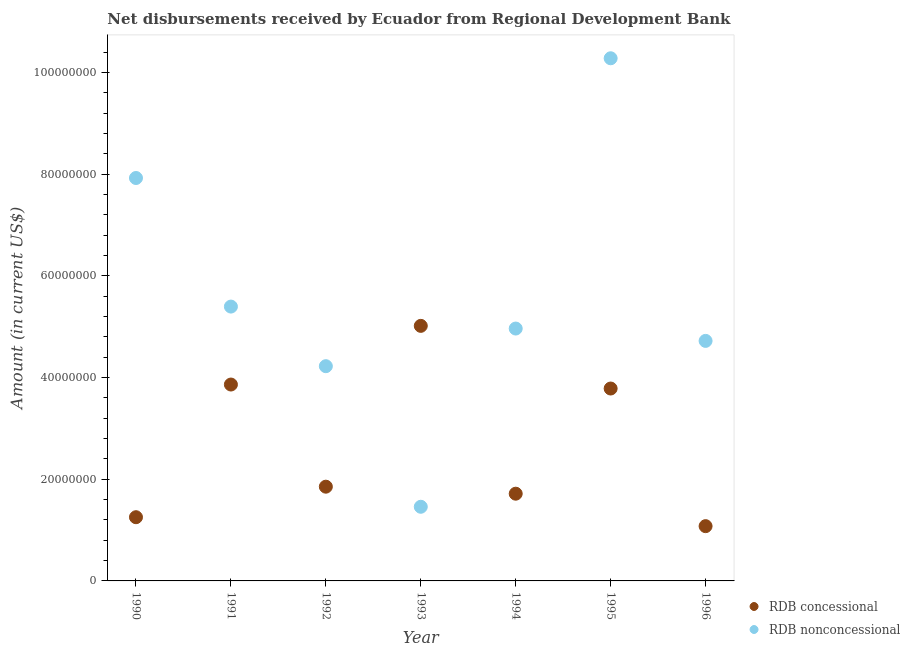Is the number of dotlines equal to the number of legend labels?
Your answer should be compact. Yes. What is the net concessional disbursements from rdb in 1991?
Ensure brevity in your answer.  3.86e+07. Across all years, what is the maximum net concessional disbursements from rdb?
Your answer should be compact. 5.02e+07. Across all years, what is the minimum net concessional disbursements from rdb?
Give a very brief answer. 1.08e+07. In which year was the net concessional disbursements from rdb maximum?
Provide a short and direct response. 1993. What is the total net non concessional disbursements from rdb in the graph?
Offer a terse response. 3.90e+08. What is the difference between the net concessional disbursements from rdb in 1990 and that in 1992?
Ensure brevity in your answer.  -6.00e+06. What is the difference between the net concessional disbursements from rdb in 1990 and the net non concessional disbursements from rdb in 1991?
Offer a terse response. -4.14e+07. What is the average net concessional disbursements from rdb per year?
Offer a terse response. 2.65e+07. In the year 1991, what is the difference between the net concessional disbursements from rdb and net non concessional disbursements from rdb?
Ensure brevity in your answer.  -1.53e+07. What is the ratio of the net concessional disbursements from rdb in 1994 to that in 1995?
Your answer should be compact. 0.45. Is the difference between the net non concessional disbursements from rdb in 1991 and 1995 greater than the difference between the net concessional disbursements from rdb in 1991 and 1995?
Make the answer very short. No. What is the difference between the highest and the second highest net non concessional disbursements from rdb?
Offer a very short reply. 2.35e+07. What is the difference between the highest and the lowest net concessional disbursements from rdb?
Offer a very short reply. 3.94e+07. In how many years, is the net non concessional disbursements from rdb greater than the average net non concessional disbursements from rdb taken over all years?
Offer a terse response. 2. Is the sum of the net concessional disbursements from rdb in 1990 and 1993 greater than the maximum net non concessional disbursements from rdb across all years?
Provide a short and direct response. No. Does the net non concessional disbursements from rdb monotonically increase over the years?
Provide a succinct answer. No. Is the net concessional disbursements from rdb strictly less than the net non concessional disbursements from rdb over the years?
Provide a short and direct response. No. How many years are there in the graph?
Provide a short and direct response. 7. What is the difference between two consecutive major ticks on the Y-axis?
Make the answer very short. 2.00e+07. Does the graph contain any zero values?
Your answer should be compact. No. Does the graph contain grids?
Provide a succinct answer. No. How are the legend labels stacked?
Provide a short and direct response. Vertical. What is the title of the graph?
Your response must be concise. Net disbursements received by Ecuador from Regional Development Bank. Does "Passenger Transport Items" appear as one of the legend labels in the graph?
Make the answer very short. No. What is the Amount (in current US$) of RDB concessional in 1990?
Give a very brief answer. 1.25e+07. What is the Amount (in current US$) in RDB nonconcessional in 1990?
Make the answer very short. 7.92e+07. What is the Amount (in current US$) in RDB concessional in 1991?
Give a very brief answer. 3.86e+07. What is the Amount (in current US$) in RDB nonconcessional in 1991?
Your answer should be compact. 5.39e+07. What is the Amount (in current US$) of RDB concessional in 1992?
Provide a short and direct response. 1.85e+07. What is the Amount (in current US$) of RDB nonconcessional in 1992?
Your answer should be compact. 4.22e+07. What is the Amount (in current US$) in RDB concessional in 1993?
Ensure brevity in your answer.  5.02e+07. What is the Amount (in current US$) of RDB nonconcessional in 1993?
Ensure brevity in your answer.  1.46e+07. What is the Amount (in current US$) in RDB concessional in 1994?
Your answer should be very brief. 1.72e+07. What is the Amount (in current US$) in RDB nonconcessional in 1994?
Your answer should be very brief. 4.96e+07. What is the Amount (in current US$) in RDB concessional in 1995?
Your answer should be compact. 3.78e+07. What is the Amount (in current US$) in RDB nonconcessional in 1995?
Ensure brevity in your answer.  1.03e+08. What is the Amount (in current US$) of RDB concessional in 1996?
Offer a very short reply. 1.08e+07. What is the Amount (in current US$) of RDB nonconcessional in 1996?
Provide a short and direct response. 4.72e+07. Across all years, what is the maximum Amount (in current US$) in RDB concessional?
Your answer should be very brief. 5.02e+07. Across all years, what is the maximum Amount (in current US$) of RDB nonconcessional?
Your answer should be compact. 1.03e+08. Across all years, what is the minimum Amount (in current US$) in RDB concessional?
Make the answer very short. 1.08e+07. Across all years, what is the minimum Amount (in current US$) of RDB nonconcessional?
Provide a short and direct response. 1.46e+07. What is the total Amount (in current US$) of RDB concessional in the graph?
Offer a terse response. 1.86e+08. What is the total Amount (in current US$) in RDB nonconcessional in the graph?
Ensure brevity in your answer.  3.90e+08. What is the difference between the Amount (in current US$) in RDB concessional in 1990 and that in 1991?
Your answer should be compact. -2.61e+07. What is the difference between the Amount (in current US$) in RDB nonconcessional in 1990 and that in 1991?
Your answer should be compact. 2.53e+07. What is the difference between the Amount (in current US$) of RDB concessional in 1990 and that in 1992?
Provide a succinct answer. -6.00e+06. What is the difference between the Amount (in current US$) of RDB nonconcessional in 1990 and that in 1992?
Your answer should be very brief. 3.70e+07. What is the difference between the Amount (in current US$) in RDB concessional in 1990 and that in 1993?
Provide a short and direct response. -3.76e+07. What is the difference between the Amount (in current US$) of RDB nonconcessional in 1990 and that in 1993?
Keep it short and to the point. 6.46e+07. What is the difference between the Amount (in current US$) in RDB concessional in 1990 and that in 1994?
Make the answer very short. -4.62e+06. What is the difference between the Amount (in current US$) of RDB nonconcessional in 1990 and that in 1994?
Offer a terse response. 2.96e+07. What is the difference between the Amount (in current US$) of RDB concessional in 1990 and that in 1995?
Your answer should be compact. -2.53e+07. What is the difference between the Amount (in current US$) of RDB nonconcessional in 1990 and that in 1995?
Keep it short and to the point. -2.35e+07. What is the difference between the Amount (in current US$) of RDB concessional in 1990 and that in 1996?
Keep it short and to the point. 1.76e+06. What is the difference between the Amount (in current US$) of RDB nonconcessional in 1990 and that in 1996?
Give a very brief answer. 3.20e+07. What is the difference between the Amount (in current US$) of RDB concessional in 1991 and that in 1992?
Make the answer very short. 2.01e+07. What is the difference between the Amount (in current US$) of RDB nonconcessional in 1991 and that in 1992?
Your response must be concise. 1.17e+07. What is the difference between the Amount (in current US$) of RDB concessional in 1991 and that in 1993?
Offer a terse response. -1.15e+07. What is the difference between the Amount (in current US$) of RDB nonconcessional in 1991 and that in 1993?
Your answer should be very brief. 3.94e+07. What is the difference between the Amount (in current US$) in RDB concessional in 1991 and that in 1994?
Provide a short and direct response. 2.15e+07. What is the difference between the Amount (in current US$) of RDB nonconcessional in 1991 and that in 1994?
Your answer should be compact. 4.32e+06. What is the difference between the Amount (in current US$) of RDB concessional in 1991 and that in 1995?
Keep it short and to the point. 7.85e+05. What is the difference between the Amount (in current US$) in RDB nonconcessional in 1991 and that in 1995?
Your answer should be very brief. -4.88e+07. What is the difference between the Amount (in current US$) of RDB concessional in 1991 and that in 1996?
Keep it short and to the point. 2.78e+07. What is the difference between the Amount (in current US$) in RDB nonconcessional in 1991 and that in 1996?
Keep it short and to the point. 6.74e+06. What is the difference between the Amount (in current US$) of RDB concessional in 1992 and that in 1993?
Your response must be concise. -3.16e+07. What is the difference between the Amount (in current US$) in RDB nonconcessional in 1992 and that in 1993?
Your response must be concise. 2.76e+07. What is the difference between the Amount (in current US$) of RDB concessional in 1992 and that in 1994?
Ensure brevity in your answer.  1.38e+06. What is the difference between the Amount (in current US$) of RDB nonconcessional in 1992 and that in 1994?
Make the answer very short. -7.40e+06. What is the difference between the Amount (in current US$) in RDB concessional in 1992 and that in 1995?
Your response must be concise. -1.93e+07. What is the difference between the Amount (in current US$) of RDB nonconcessional in 1992 and that in 1995?
Provide a short and direct response. -6.05e+07. What is the difference between the Amount (in current US$) in RDB concessional in 1992 and that in 1996?
Provide a succinct answer. 7.76e+06. What is the difference between the Amount (in current US$) in RDB nonconcessional in 1992 and that in 1996?
Your answer should be very brief. -4.97e+06. What is the difference between the Amount (in current US$) of RDB concessional in 1993 and that in 1994?
Make the answer very short. 3.30e+07. What is the difference between the Amount (in current US$) in RDB nonconcessional in 1993 and that in 1994?
Provide a short and direct response. -3.50e+07. What is the difference between the Amount (in current US$) in RDB concessional in 1993 and that in 1995?
Your answer should be compact. 1.23e+07. What is the difference between the Amount (in current US$) in RDB nonconcessional in 1993 and that in 1995?
Make the answer very short. -8.82e+07. What is the difference between the Amount (in current US$) of RDB concessional in 1993 and that in 1996?
Make the answer very short. 3.94e+07. What is the difference between the Amount (in current US$) of RDB nonconcessional in 1993 and that in 1996?
Provide a succinct answer. -3.26e+07. What is the difference between the Amount (in current US$) in RDB concessional in 1994 and that in 1995?
Give a very brief answer. -2.07e+07. What is the difference between the Amount (in current US$) in RDB nonconcessional in 1994 and that in 1995?
Your response must be concise. -5.31e+07. What is the difference between the Amount (in current US$) of RDB concessional in 1994 and that in 1996?
Ensure brevity in your answer.  6.38e+06. What is the difference between the Amount (in current US$) in RDB nonconcessional in 1994 and that in 1996?
Keep it short and to the point. 2.43e+06. What is the difference between the Amount (in current US$) of RDB concessional in 1995 and that in 1996?
Give a very brief answer. 2.71e+07. What is the difference between the Amount (in current US$) of RDB nonconcessional in 1995 and that in 1996?
Provide a short and direct response. 5.56e+07. What is the difference between the Amount (in current US$) of RDB concessional in 1990 and the Amount (in current US$) of RDB nonconcessional in 1991?
Ensure brevity in your answer.  -4.14e+07. What is the difference between the Amount (in current US$) in RDB concessional in 1990 and the Amount (in current US$) in RDB nonconcessional in 1992?
Your answer should be compact. -2.97e+07. What is the difference between the Amount (in current US$) in RDB concessional in 1990 and the Amount (in current US$) in RDB nonconcessional in 1993?
Your answer should be compact. -2.05e+06. What is the difference between the Amount (in current US$) in RDB concessional in 1990 and the Amount (in current US$) in RDB nonconcessional in 1994?
Keep it short and to the point. -3.71e+07. What is the difference between the Amount (in current US$) in RDB concessional in 1990 and the Amount (in current US$) in RDB nonconcessional in 1995?
Your response must be concise. -9.02e+07. What is the difference between the Amount (in current US$) of RDB concessional in 1990 and the Amount (in current US$) of RDB nonconcessional in 1996?
Offer a terse response. -3.47e+07. What is the difference between the Amount (in current US$) of RDB concessional in 1991 and the Amount (in current US$) of RDB nonconcessional in 1992?
Offer a terse response. -3.61e+06. What is the difference between the Amount (in current US$) in RDB concessional in 1991 and the Amount (in current US$) in RDB nonconcessional in 1993?
Provide a succinct answer. 2.40e+07. What is the difference between the Amount (in current US$) in RDB concessional in 1991 and the Amount (in current US$) in RDB nonconcessional in 1994?
Provide a succinct answer. -1.10e+07. What is the difference between the Amount (in current US$) in RDB concessional in 1991 and the Amount (in current US$) in RDB nonconcessional in 1995?
Offer a very short reply. -6.42e+07. What is the difference between the Amount (in current US$) of RDB concessional in 1991 and the Amount (in current US$) of RDB nonconcessional in 1996?
Your response must be concise. -8.58e+06. What is the difference between the Amount (in current US$) in RDB concessional in 1992 and the Amount (in current US$) in RDB nonconcessional in 1993?
Give a very brief answer. 3.95e+06. What is the difference between the Amount (in current US$) in RDB concessional in 1992 and the Amount (in current US$) in RDB nonconcessional in 1994?
Make the answer very short. -3.11e+07. What is the difference between the Amount (in current US$) in RDB concessional in 1992 and the Amount (in current US$) in RDB nonconcessional in 1995?
Your answer should be compact. -8.42e+07. What is the difference between the Amount (in current US$) of RDB concessional in 1992 and the Amount (in current US$) of RDB nonconcessional in 1996?
Offer a terse response. -2.87e+07. What is the difference between the Amount (in current US$) in RDB concessional in 1993 and the Amount (in current US$) in RDB nonconcessional in 1994?
Provide a succinct answer. 5.28e+05. What is the difference between the Amount (in current US$) of RDB concessional in 1993 and the Amount (in current US$) of RDB nonconcessional in 1995?
Ensure brevity in your answer.  -5.26e+07. What is the difference between the Amount (in current US$) in RDB concessional in 1993 and the Amount (in current US$) in RDB nonconcessional in 1996?
Offer a very short reply. 2.96e+06. What is the difference between the Amount (in current US$) in RDB concessional in 1994 and the Amount (in current US$) in RDB nonconcessional in 1995?
Your answer should be very brief. -8.56e+07. What is the difference between the Amount (in current US$) of RDB concessional in 1994 and the Amount (in current US$) of RDB nonconcessional in 1996?
Make the answer very short. -3.00e+07. What is the difference between the Amount (in current US$) of RDB concessional in 1995 and the Amount (in current US$) of RDB nonconcessional in 1996?
Provide a short and direct response. -9.37e+06. What is the average Amount (in current US$) of RDB concessional per year?
Make the answer very short. 2.65e+07. What is the average Amount (in current US$) of RDB nonconcessional per year?
Give a very brief answer. 5.57e+07. In the year 1990, what is the difference between the Amount (in current US$) of RDB concessional and Amount (in current US$) of RDB nonconcessional?
Give a very brief answer. -6.67e+07. In the year 1991, what is the difference between the Amount (in current US$) in RDB concessional and Amount (in current US$) in RDB nonconcessional?
Provide a short and direct response. -1.53e+07. In the year 1992, what is the difference between the Amount (in current US$) in RDB concessional and Amount (in current US$) in RDB nonconcessional?
Provide a succinct answer. -2.37e+07. In the year 1993, what is the difference between the Amount (in current US$) in RDB concessional and Amount (in current US$) in RDB nonconcessional?
Provide a succinct answer. 3.56e+07. In the year 1994, what is the difference between the Amount (in current US$) of RDB concessional and Amount (in current US$) of RDB nonconcessional?
Your response must be concise. -3.25e+07. In the year 1995, what is the difference between the Amount (in current US$) in RDB concessional and Amount (in current US$) in RDB nonconcessional?
Offer a terse response. -6.49e+07. In the year 1996, what is the difference between the Amount (in current US$) in RDB concessional and Amount (in current US$) in RDB nonconcessional?
Make the answer very short. -3.64e+07. What is the ratio of the Amount (in current US$) of RDB concessional in 1990 to that in 1991?
Provide a succinct answer. 0.32. What is the ratio of the Amount (in current US$) of RDB nonconcessional in 1990 to that in 1991?
Offer a very short reply. 1.47. What is the ratio of the Amount (in current US$) of RDB concessional in 1990 to that in 1992?
Ensure brevity in your answer.  0.68. What is the ratio of the Amount (in current US$) of RDB nonconcessional in 1990 to that in 1992?
Ensure brevity in your answer.  1.88. What is the ratio of the Amount (in current US$) of RDB concessional in 1990 to that in 1993?
Your response must be concise. 0.25. What is the ratio of the Amount (in current US$) of RDB nonconcessional in 1990 to that in 1993?
Offer a very short reply. 5.43. What is the ratio of the Amount (in current US$) in RDB concessional in 1990 to that in 1994?
Your answer should be very brief. 0.73. What is the ratio of the Amount (in current US$) in RDB nonconcessional in 1990 to that in 1994?
Ensure brevity in your answer.  1.6. What is the ratio of the Amount (in current US$) of RDB concessional in 1990 to that in 1995?
Offer a terse response. 0.33. What is the ratio of the Amount (in current US$) of RDB nonconcessional in 1990 to that in 1995?
Provide a succinct answer. 0.77. What is the ratio of the Amount (in current US$) of RDB concessional in 1990 to that in 1996?
Your response must be concise. 1.16. What is the ratio of the Amount (in current US$) in RDB nonconcessional in 1990 to that in 1996?
Your response must be concise. 1.68. What is the ratio of the Amount (in current US$) in RDB concessional in 1991 to that in 1992?
Your answer should be compact. 2.08. What is the ratio of the Amount (in current US$) of RDB nonconcessional in 1991 to that in 1992?
Make the answer very short. 1.28. What is the ratio of the Amount (in current US$) of RDB concessional in 1991 to that in 1993?
Ensure brevity in your answer.  0.77. What is the ratio of the Amount (in current US$) of RDB nonconcessional in 1991 to that in 1993?
Your answer should be very brief. 3.7. What is the ratio of the Amount (in current US$) of RDB concessional in 1991 to that in 1994?
Keep it short and to the point. 2.25. What is the ratio of the Amount (in current US$) of RDB nonconcessional in 1991 to that in 1994?
Offer a terse response. 1.09. What is the ratio of the Amount (in current US$) of RDB concessional in 1991 to that in 1995?
Provide a short and direct response. 1.02. What is the ratio of the Amount (in current US$) in RDB nonconcessional in 1991 to that in 1995?
Provide a succinct answer. 0.52. What is the ratio of the Amount (in current US$) in RDB concessional in 1991 to that in 1996?
Provide a short and direct response. 3.59. What is the ratio of the Amount (in current US$) in RDB concessional in 1992 to that in 1993?
Your response must be concise. 0.37. What is the ratio of the Amount (in current US$) of RDB nonconcessional in 1992 to that in 1993?
Keep it short and to the point. 2.9. What is the ratio of the Amount (in current US$) in RDB concessional in 1992 to that in 1994?
Your answer should be compact. 1.08. What is the ratio of the Amount (in current US$) of RDB nonconcessional in 1992 to that in 1994?
Your response must be concise. 0.85. What is the ratio of the Amount (in current US$) in RDB concessional in 1992 to that in 1995?
Give a very brief answer. 0.49. What is the ratio of the Amount (in current US$) of RDB nonconcessional in 1992 to that in 1995?
Offer a very short reply. 0.41. What is the ratio of the Amount (in current US$) of RDB concessional in 1992 to that in 1996?
Make the answer very short. 1.72. What is the ratio of the Amount (in current US$) in RDB nonconcessional in 1992 to that in 1996?
Your answer should be very brief. 0.89. What is the ratio of the Amount (in current US$) in RDB concessional in 1993 to that in 1994?
Provide a succinct answer. 2.92. What is the ratio of the Amount (in current US$) in RDB nonconcessional in 1993 to that in 1994?
Your answer should be compact. 0.29. What is the ratio of the Amount (in current US$) in RDB concessional in 1993 to that in 1995?
Your response must be concise. 1.33. What is the ratio of the Amount (in current US$) in RDB nonconcessional in 1993 to that in 1995?
Your answer should be very brief. 0.14. What is the ratio of the Amount (in current US$) of RDB concessional in 1993 to that in 1996?
Your response must be concise. 4.66. What is the ratio of the Amount (in current US$) in RDB nonconcessional in 1993 to that in 1996?
Your response must be concise. 0.31. What is the ratio of the Amount (in current US$) in RDB concessional in 1994 to that in 1995?
Your response must be concise. 0.45. What is the ratio of the Amount (in current US$) of RDB nonconcessional in 1994 to that in 1995?
Ensure brevity in your answer.  0.48. What is the ratio of the Amount (in current US$) in RDB concessional in 1994 to that in 1996?
Keep it short and to the point. 1.59. What is the ratio of the Amount (in current US$) of RDB nonconcessional in 1994 to that in 1996?
Make the answer very short. 1.05. What is the ratio of the Amount (in current US$) of RDB concessional in 1995 to that in 1996?
Keep it short and to the point. 3.51. What is the ratio of the Amount (in current US$) of RDB nonconcessional in 1995 to that in 1996?
Your answer should be very brief. 2.18. What is the difference between the highest and the second highest Amount (in current US$) in RDB concessional?
Offer a very short reply. 1.15e+07. What is the difference between the highest and the second highest Amount (in current US$) of RDB nonconcessional?
Your answer should be very brief. 2.35e+07. What is the difference between the highest and the lowest Amount (in current US$) in RDB concessional?
Provide a short and direct response. 3.94e+07. What is the difference between the highest and the lowest Amount (in current US$) in RDB nonconcessional?
Keep it short and to the point. 8.82e+07. 